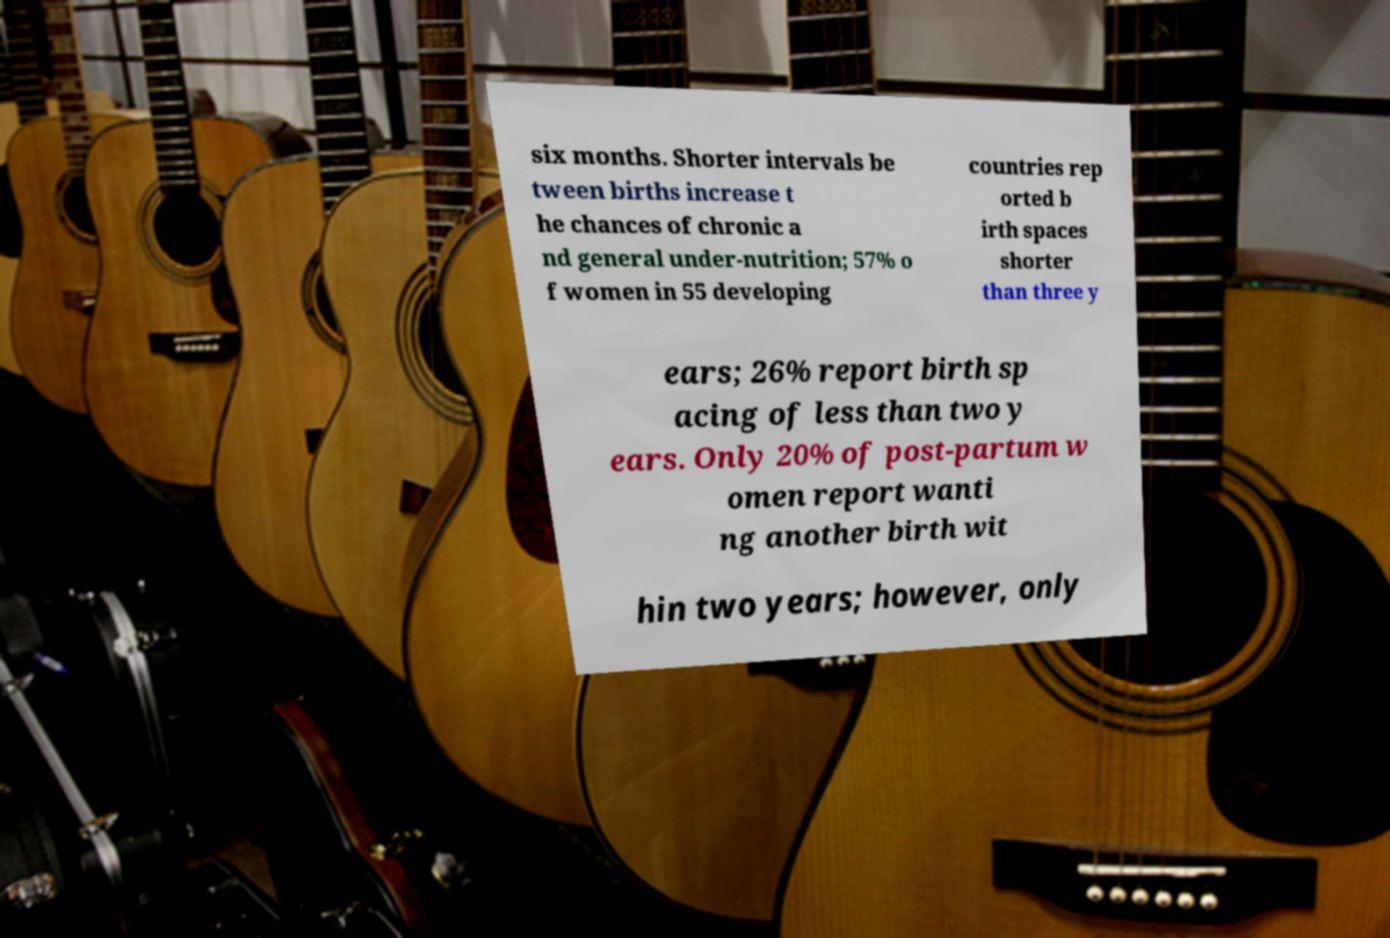Please read and relay the text visible in this image. What does it say? six months. Shorter intervals be tween births increase t he chances of chronic a nd general under-nutrition; 57% o f women in 55 developing countries rep orted b irth spaces shorter than three y ears; 26% report birth sp acing of less than two y ears. Only 20% of post-partum w omen report wanti ng another birth wit hin two years; however, only 